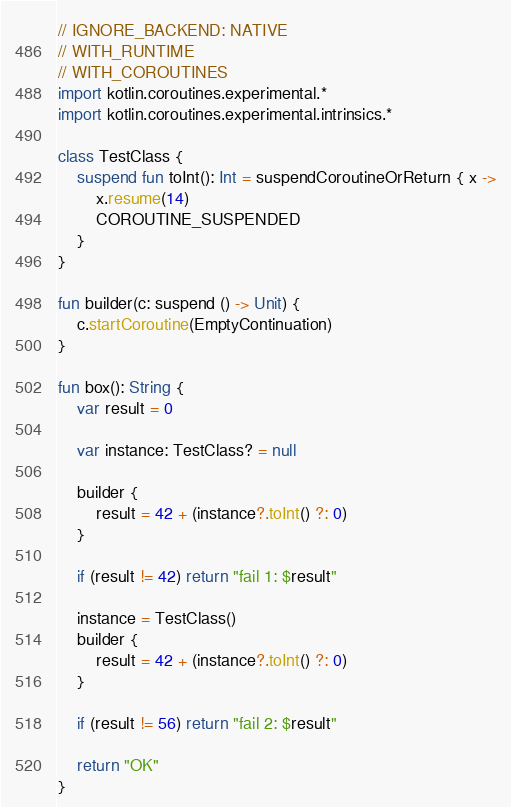Convert code to text. <code><loc_0><loc_0><loc_500><loc_500><_Kotlin_>// IGNORE_BACKEND: NATIVE
// WITH_RUNTIME
// WITH_COROUTINES
import kotlin.coroutines.experimental.*
import kotlin.coroutines.experimental.intrinsics.*

class TestClass {
    suspend fun toInt(): Int = suspendCoroutineOrReturn { x ->
        x.resume(14)
        COROUTINE_SUSPENDED
    }
}

fun builder(c: suspend () -> Unit) {
    c.startCoroutine(EmptyContinuation)
}

fun box(): String {
    var result = 0

    var instance: TestClass? = null

    builder {
        result = 42 + (instance?.toInt() ?: 0)
    }

    if (result != 42) return "fail 1: $result"

    instance = TestClass()
    builder {
        result = 42 + (instance?.toInt() ?: 0)
    }

    if (result != 56) return "fail 2: $result"

    return "OK"
}
</code> 